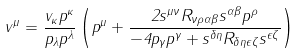Convert formula to latex. <formula><loc_0><loc_0><loc_500><loc_500>v ^ { \mu } = \frac { v _ { \kappa } p ^ { \kappa } } { p _ { \lambda } p ^ { \lambda } } \left ( p ^ { \mu } + \frac { 2 s ^ { \mu \nu } R _ { \nu \rho \alpha \beta } s ^ { \alpha \beta } p ^ { \rho } } { - 4 p _ { \gamma } p ^ { \gamma } + s ^ { \delta \eta } R _ { \delta \eta \epsilon \zeta } s ^ { \epsilon \zeta } } \right )</formula> 